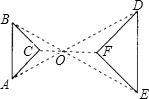Can you explain the concept of similar triangles as shown in this image? Certainly, similar triangles have the same shape but differ in size. This means all corresponding angles are equal and the lengths of corresponding sides are in the same ratio. In this image, triangles ABC and DEF are similar, drawn concentrically around point 'O'. To confirm their similarity, we would verify that each angle in triangle ABC is congruent to its corresponding angle in triangle DEF, and the sides are proportional, which the image hints at but does not explicitly confirm with measurements. 